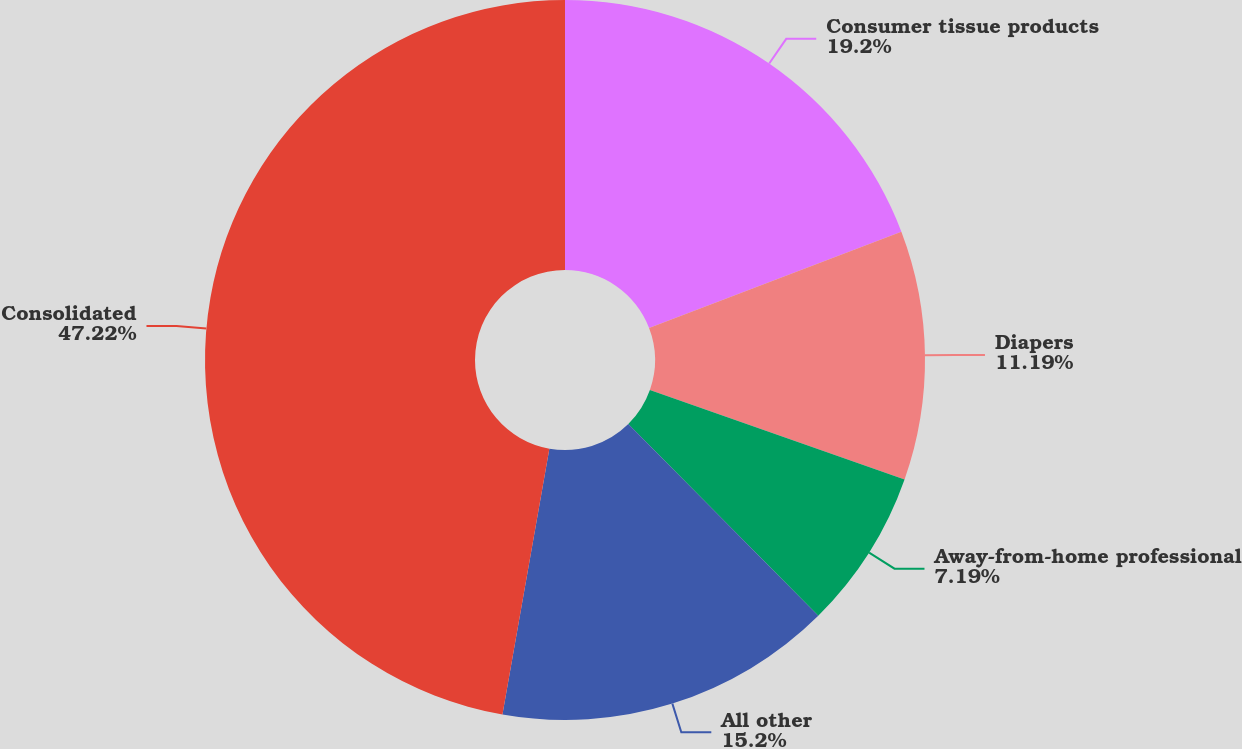<chart> <loc_0><loc_0><loc_500><loc_500><pie_chart><fcel>Consumer tissue products<fcel>Diapers<fcel>Away-from-home professional<fcel>All other<fcel>Consolidated<nl><fcel>19.2%<fcel>11.19%<fcel>7.19%<fcel>15.2%<fcel>47.22%<nl></chart> 